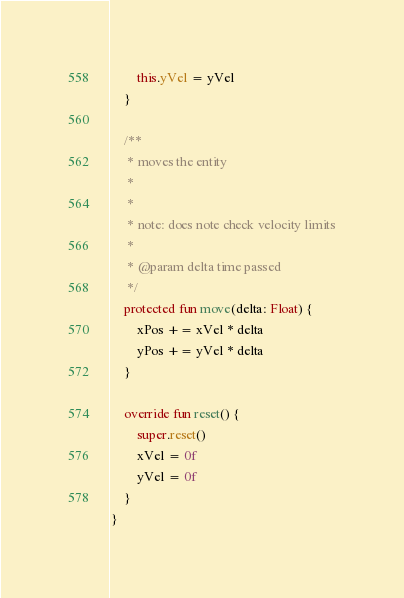Convert code to text. <code><loc_0><loc_0><loc_500><loc_500><_Kotlin_>        this.yVel = yVel
    }

    /**
     * moves the entity
     *
     *
     * note: does note check velocity limits
     *
     * @param delta time passed
     */
    protected fun move(delta: Float) {
        xPos += xVel * delta
        yPos += yVel * delta
    }

    override fun reset() {
        super.reset()
        xVel = 0f
        yVel = 0f
    }
}
</code> 